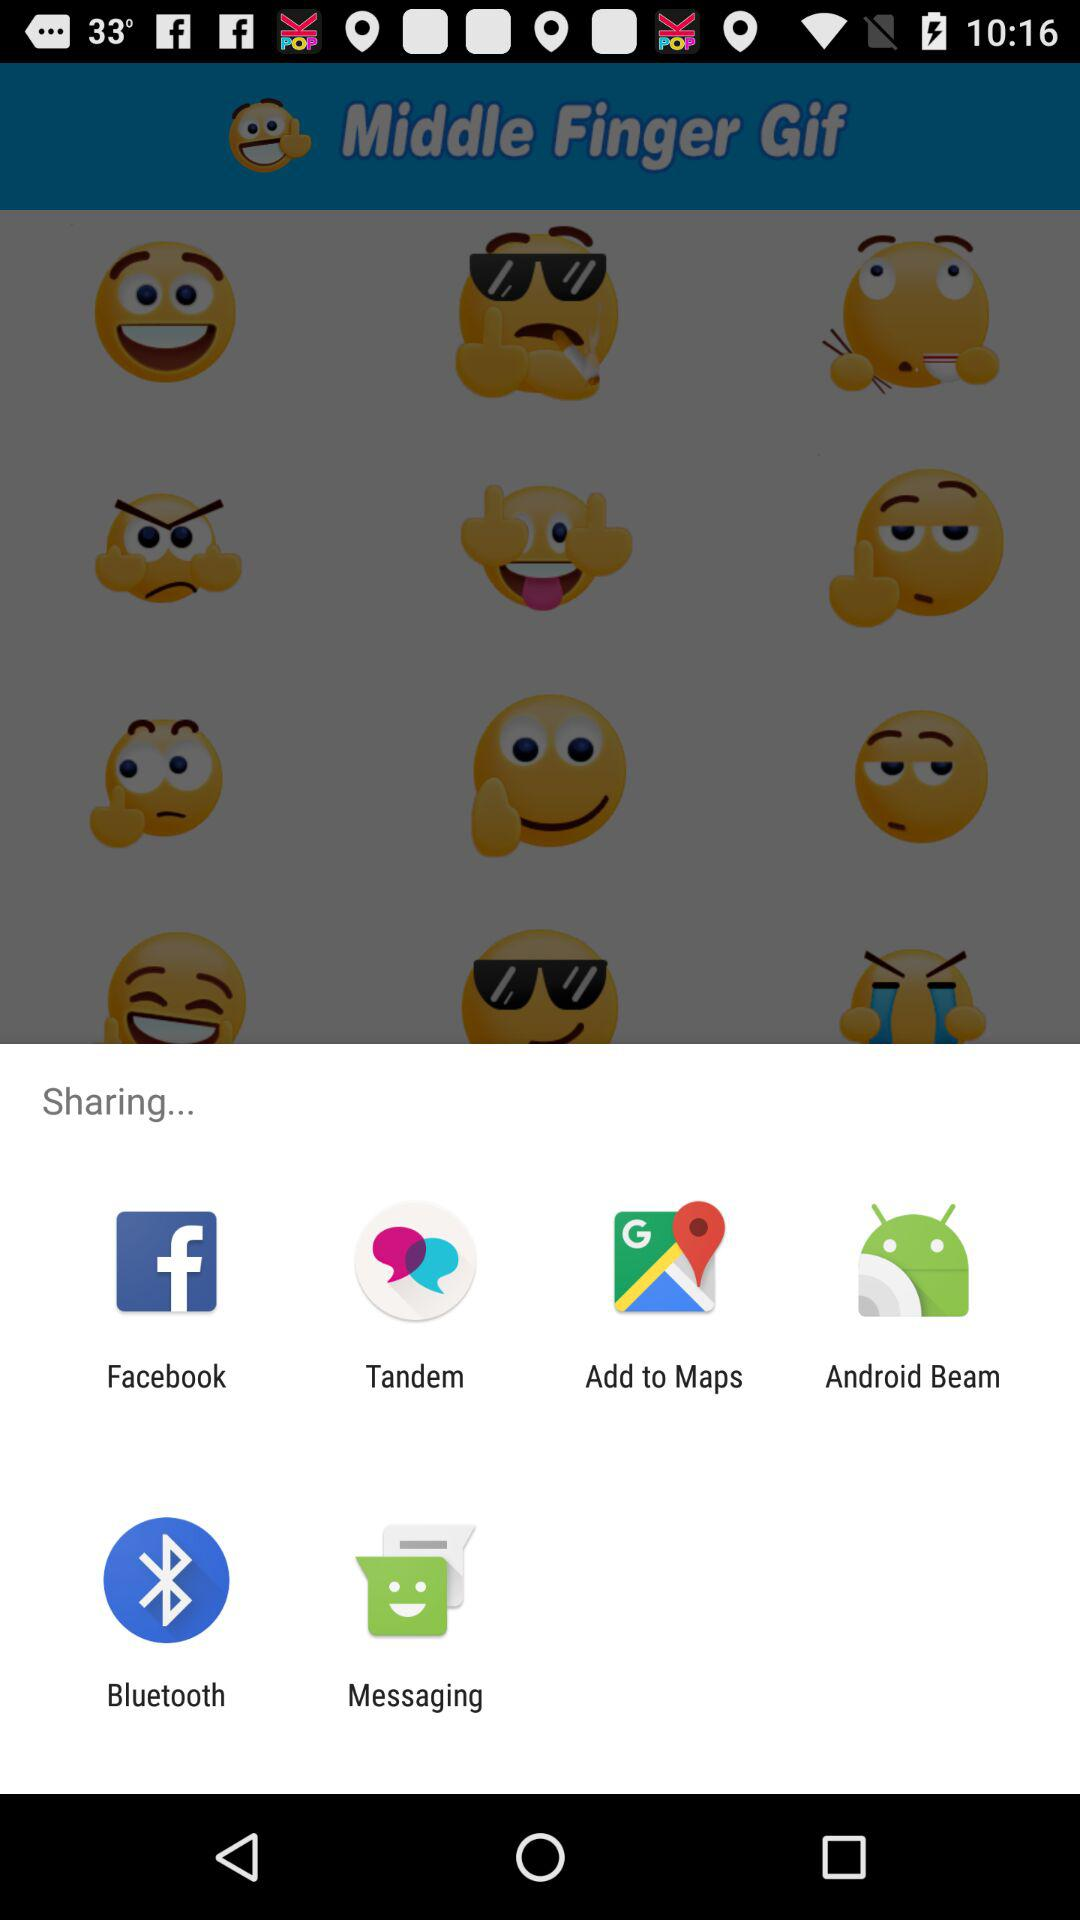Which middle finger GIF is selected?
When the provided information is insufficient, respond with <no answer>. <no answer> 